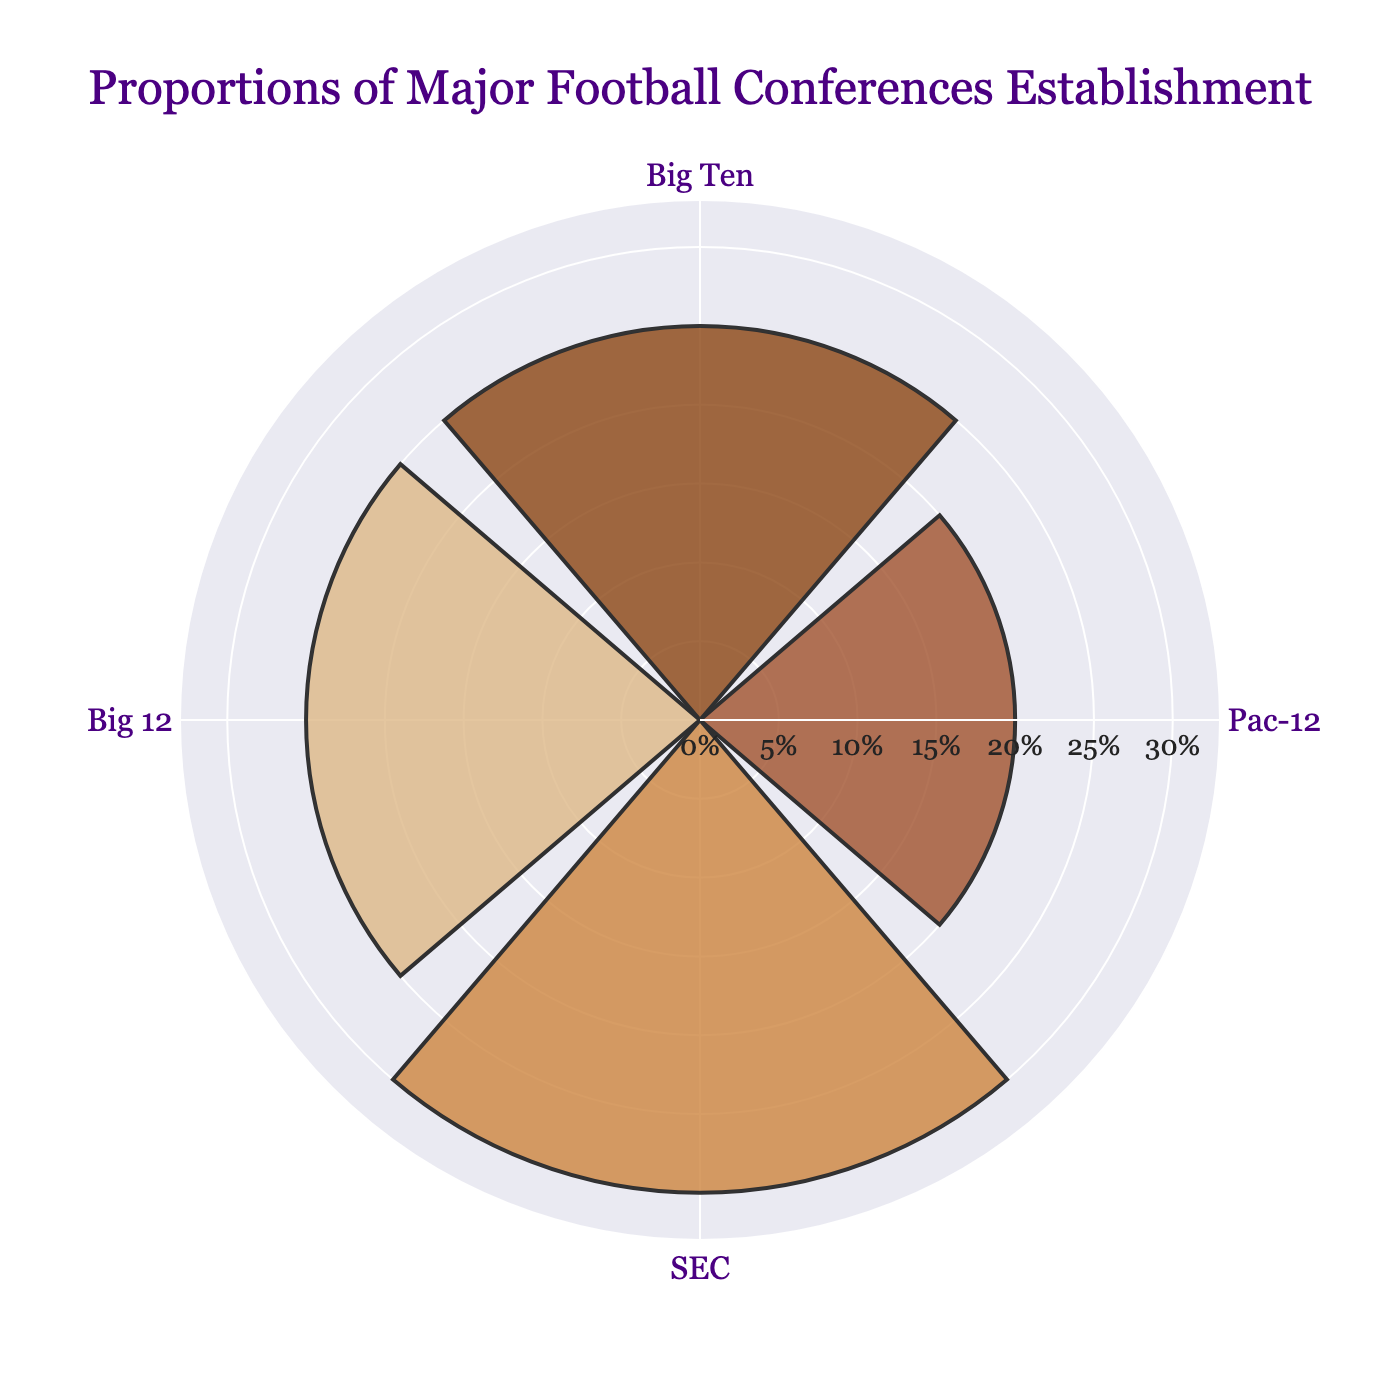How many conferences are represented in the figure? The figure shows four different conference names in the theta (angular) axis.
Answer: Four What is the title of the figure? The title is displayed at the top of the figure and reads "Proportions of Major Football Conferences Establishment".
Answer: Proportions of Major Football Conferences Establishment Which conference has the highest proportion? By observing the length of the bars, the SEC conference has the longest radial bar, indicating the highest proportion.
Answer: SEC Which conferences have equal proportions? The radial bars for Big Ten and Big 12 are of equal length.
Answer: Big Ten and Big 12 What is the sum of the proportions of the Pac-12 and Big Ten conferences? The proportion for Pac-12 is 0.20 and for Big Ten is 0.25. Adding these values gives 0.20 + 0.25 = 0.45.
Answer: 0.45 What is the difference between the proportions of the SEC and Pac-12 conferences? The proportion for SEC is 0.30 and for Pac-12 is 0.20. Subtracting these values gives 0.30 - 0.20 = 0.10.
Answer: 0.10 Which conference has a 25% proportion? Observing the radial bars, Big Ten and Big 12 conferences both have proportions of 0.25, which is 25%.
Answer: Big Ten and Big 12 What is the average proportion of all the conferences? The proportions are 0.25 (Big Ten), 0.20 (Pac-12), 0.30 (SEC), and 0.25 (Big 12). The average is (0.25 + 0.20 + 0.30 + 0.25) / 4 = 1.00 / 4 = 0.25.
Answer: 0.25 Which conference is closest to the average proportion? The average proportion is 0.25. Big Ten and Big 12 both have a proportion of 0.25, which matches the average exactly.
Answer: Big Ten and Big 12 